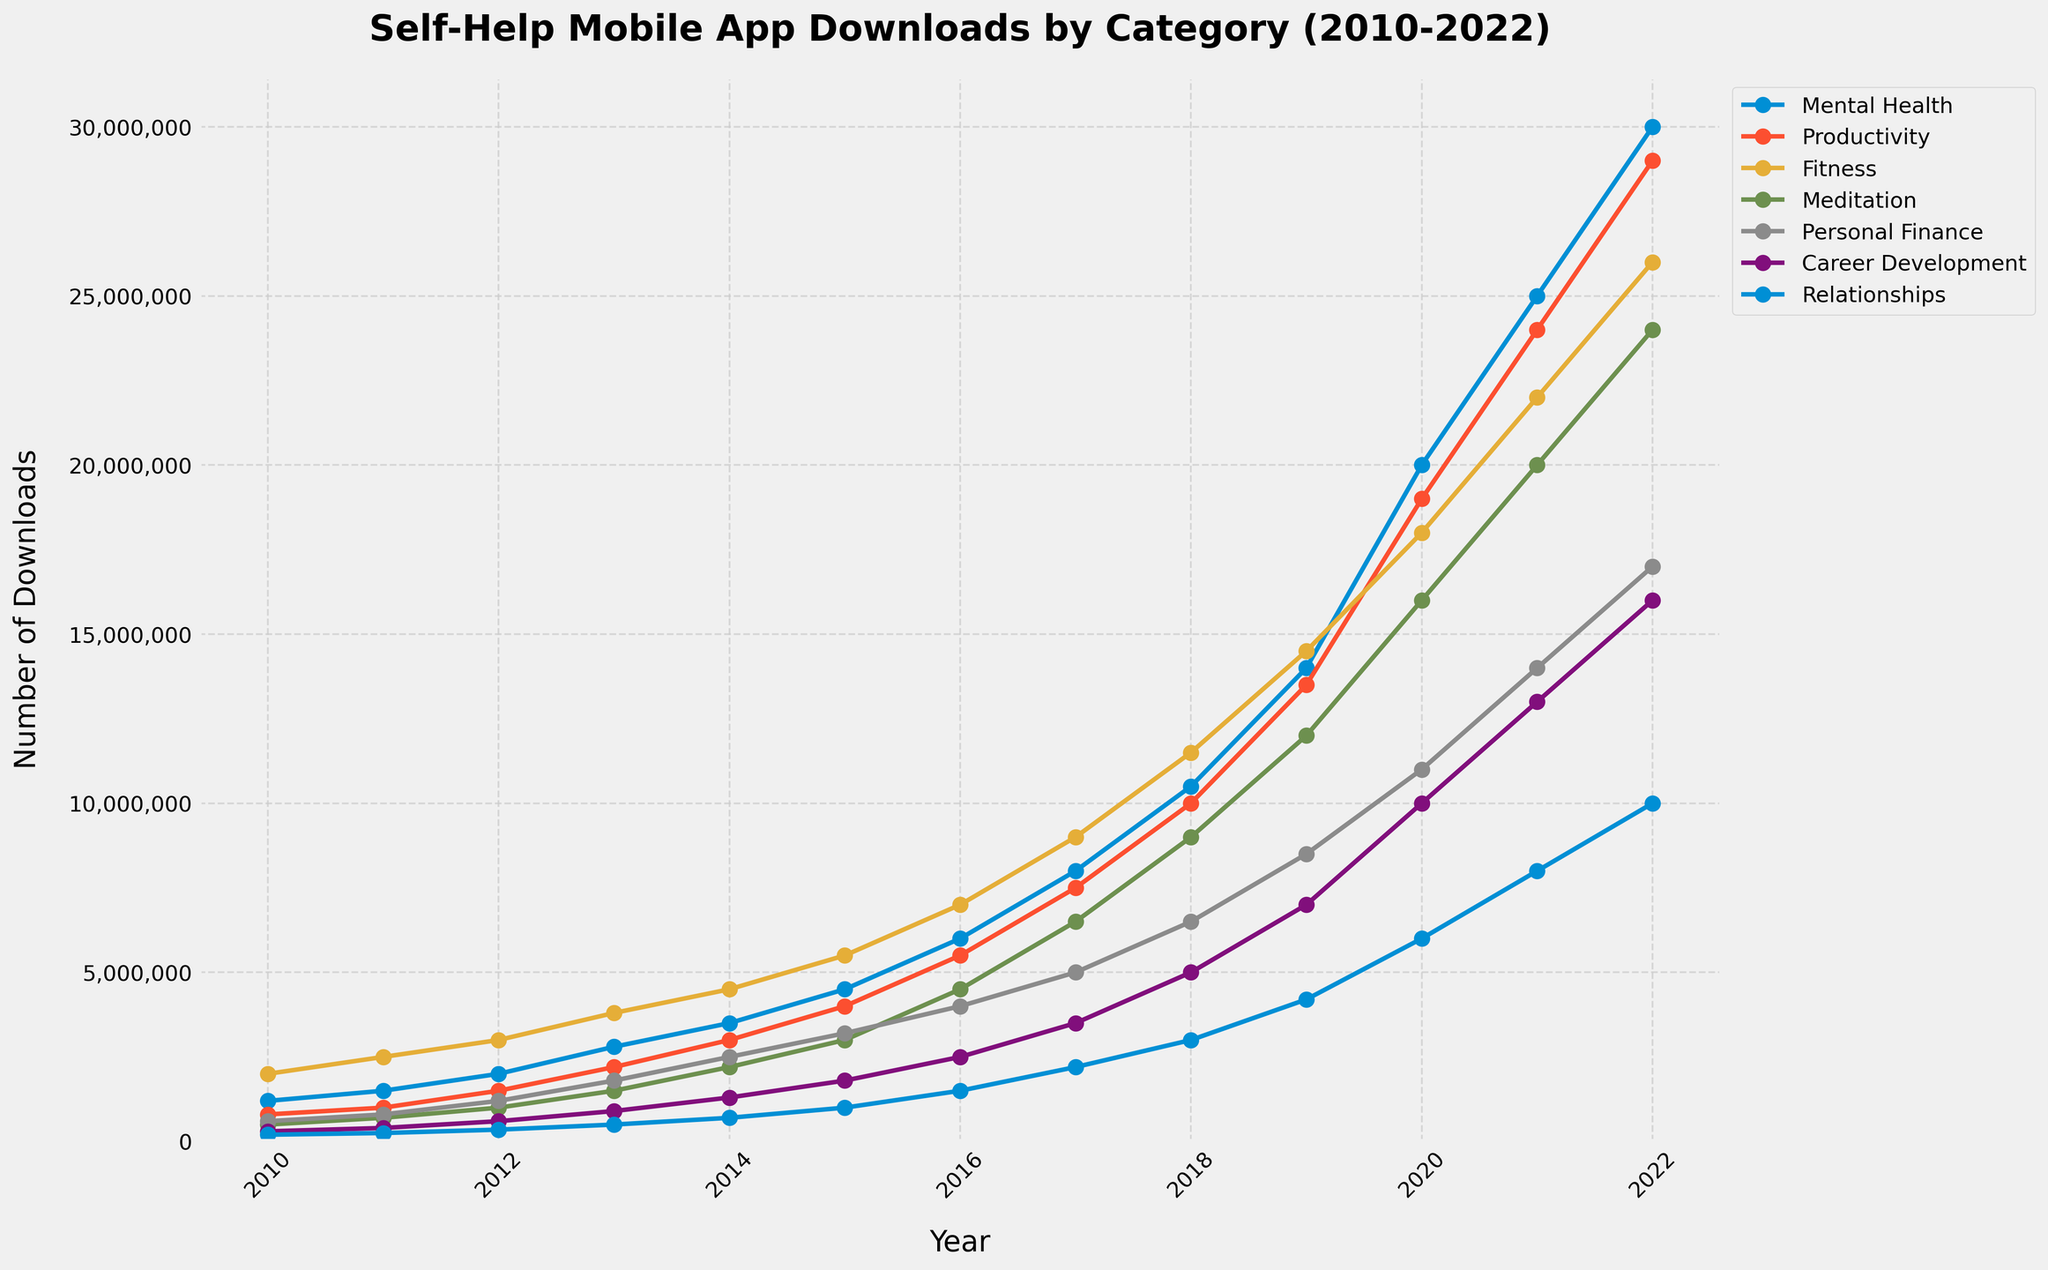what category had the highest number of downloads in 2022? The figure shows the trends for different categories over the years. In 2022, the category with the highest number of downloads is "Mental Health" with 30,000,000 downloads.
Answer: Mental Health Between which two years did the "Meditation" category experience the largest increase in downloads? To find this, one must look at the changes in the number of downloads year by year. The largest increase for the "Meditation" category is between 2019 and 2020, where downloads went from 12,000,000 to 16,000,000, a difference of 4,000,000 downloads.
Answer: 2019 and 2020 What's the total number of "Productivity" app downloads from 2015 to 2020? Add the number of downloads from 2015 to 2020 for the "Productivity" category: 4,000,000 (2015) + 5,500,000 (2016) + 7,500,000 (2017) + 10,000,000 (2018) + 13,500,000 (2019) + 19,000,000 (2020) = 59,500,000 downloads.
Answer: 59,500,000 How many categories had more than 10,000,000 downloads in 2022? Count all categories in 2022 with more than 10,000,000 downloads: "Mental Health" (30,000,000), "Productivity" (29,000,000), "Fitness" (26,000,000), "Meditation" (24,000,000), "Personal Finance" (17,000,000), "Career Development" (16,000,000). There are 6 categories in total.
Answer: 6 Which category had more downloads in 2013: "Personal Finance" or "Career Development"? Compare the download figures for 2013. "Personal Finance" had 1,800,000 downloads, while "Career Development" had 900,000 downloads. Therefore, "Personal Finance" had more downloads.
Answer: Personal Finance In which year did the "Fitness" category surpass 10,000,000 downloads? Look for the year where "Fitness" downloads first exceed 10,000,000. This occurred in 2018, where downloads were 11,500,000.
Answer: 2018 What is the average annual increase in downloads for the "Relationships" category from 2010 to 2022? Calculate the average increase: (Value in 2022 - Value in 2010) / Number of years = (10,000,000 - 200,000) / 12 = 9,800,000 / 12 ≈ 816,667 downloads per year.
Answer: 816,667 Which category showed the most consistent growth over the years, based on visual inspection? By inspecting the lines, "Mental Health" seems to have the most consistent and steady growth between 2010 and 2022 without any sudden spikes or drops.
Answer: Mental Health How does the increase in downloads from 2019 to 2020 for "Personal Finance" compare to that of "Career Development"? Calculate the increase for both: "Personal Finance" from 2019 to 2020 increased from 8,500,000 to 11,000,000 (an increase of 2,500,000). "Career Development" from 2019 to 2020 increased from 7,000,000 to 10,000,000 (an increase of 3,000,000). Hence, "Career Development" had a larger increase.
Answer: Career Development 